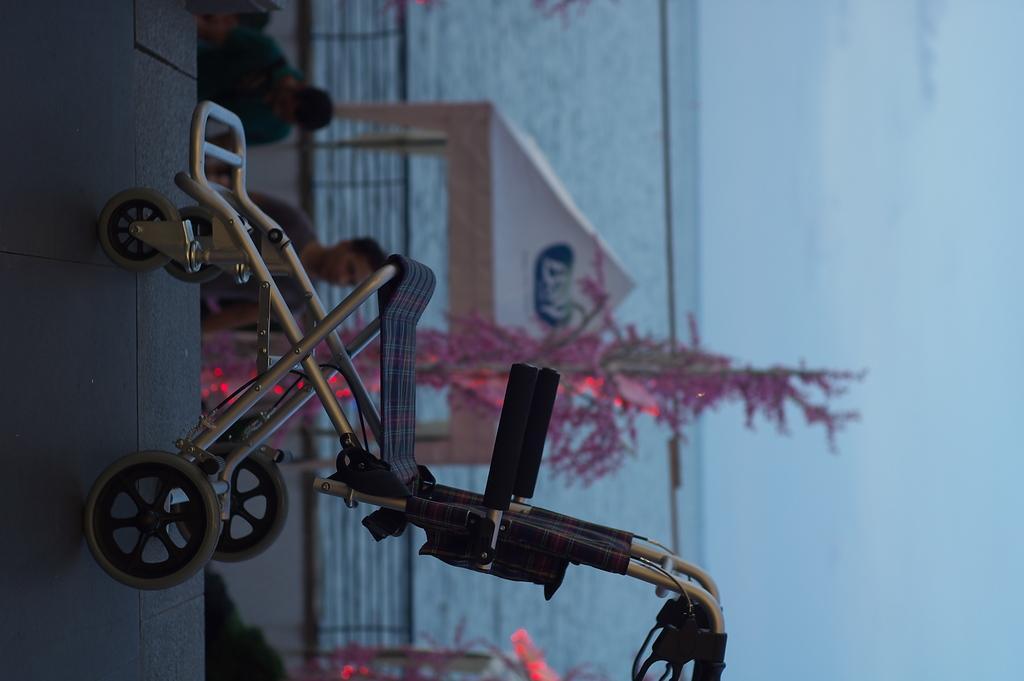Please provide a concise description of this image. This image consists of a wheelchair in the middle. There is water in the middle. There is a plant in the middle. There is the sky on the right side. 